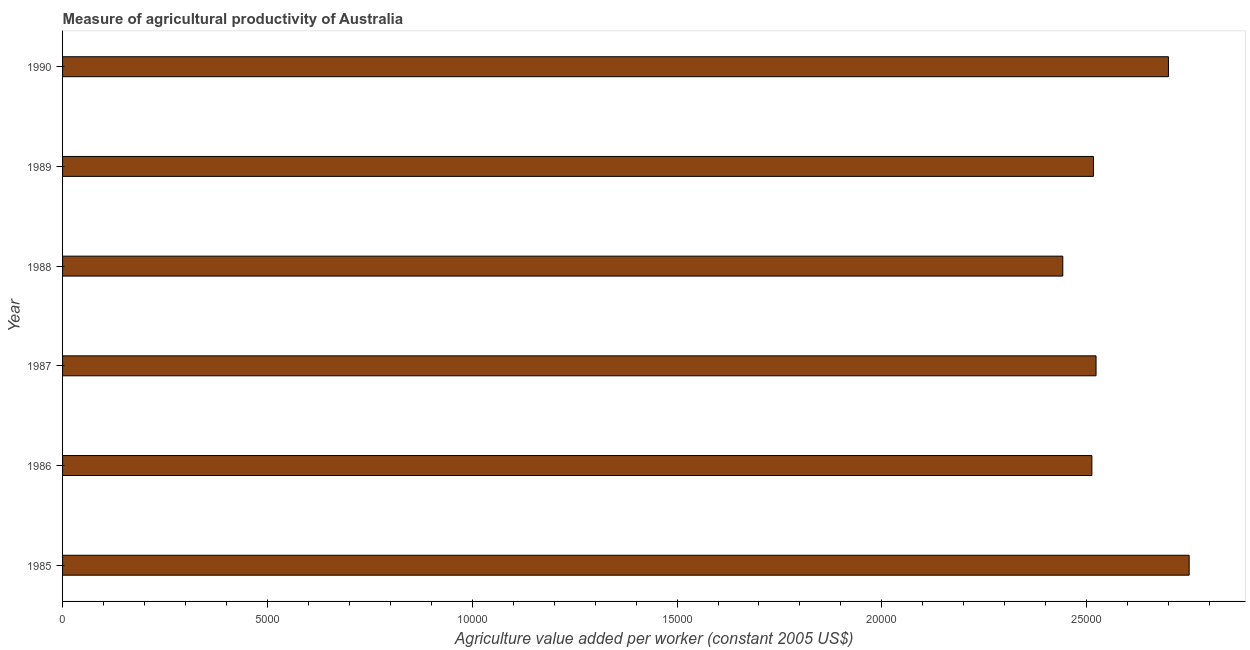Does the graph contain any zero values?
Provide a short and direct response. No. What is the title of the graph?
Keep it short and to the point. Measure of agricultural productivity of Australia. What is the label or title of the X-axis?
Your answer should be very brief. Agriculture value added per worker (constant 2005 US$). What is the agriculture value added per worker in 1989?
Your answer should be compact. 2.52e+04. Across all years, what is the maximum agriculture value added per worker?
Provide a succinct answer. 2.75e+04. Across all years, what is the minimum agriculture value added per worker?
Your response must be concise. 2.44e+04. What is the sum of the agriculture value added per worker?
Ensure brevity in your answer.  1.54e+05. What is the difference between the agriculture value added per worker in 1986 and 1988?
Make the answer very short. 710.05. What is the average agriculture value added per worker per year?
Offer a very short reply. 2.57e+04. What is the median agriculture value added per worker?
Make the answer very short. 2.52e+04. In how many years, is the agriculture value added per worker greater than 9000 US$?
Make the answer very short. 6. Is the agriculture value added per worker in 1989 less than that in 1990?
Your answer should be compact. Yes. What is the difference between the highest and the second highest agriculture value added per worker?
Offer a terse response. 506.07. What is the difference between the highest and the lowest agriculture value added per worker?
Provide a short and direct response. 3084.77. In how many years, is the agriculture value added per worker greater than the average agriculture value added per worker taken over all years?
Provide a succinct answer. 2. How many years are there in the graph?
Your answer should be compact. 6. What is the difference between two consecutive major ticks on the X-axis?
Give a very brief answer. 5000. What is the Agriculture value added per worker (constant 2005 US$) of 1985?
Your answer should be very brief. 2.75e+04. What is the Agriculture value added per worker (constant 2005 US$) of 1986?
Give a very brief answer. 2.51e+04. What is the Agriculture value added per worker (constant 2005 US$) in 1987?
Keep it short and to the point. 2.52e+04. What is the Agriculture value added per worker (constant 2005 US$) in 1988?
Provide a succinct answer. 2.44e+04. What is the Agriculture value added per worker (constant 2005 US$) of 1989?
Ensure brevity in your answer.  2.52e+04. What is the Agriculture value added per worker (constant 2005 US$) of 1990?
Your response must be concise. 2.70e+04. What is the difference between the Agriculture value added per worker (constant 2005 US$) in 1985 and 1986?
Your answer should be very brief. 2374.72. What is the difference between the Agriculture value added per worker (constant 2005 US$) in 1985 and 1987?
Give a very brief answer. 2272.86. What is the difference between the Agriculture value added per worker (constant 2005 US$) in 1985 and 1988?
Provide a short and direct response. 3084.77. What is the difference between the Agriculture value added per worker (constant 2005 US$) in 1985 and 1989?
Your response must be concise. 2336.24. What is the difference between the Agriculture value added per worker (constant 2005 US$) in 1985 and 1990?
Make the answer very short. 506.07. What is the difference between the Agriculture value added per worker (constant 2005 US$) in 1986 and 1987?
Provide a short and direct response. -101.86. What is the difference between the Agriculture value added per worker (constant 2005 US$) in 1986 and 1988?
Make the answer very short. 710.05. What is the difference between the Agriculture value added per worker (constant 2005 US$) in 1986 and 1989?
Make the answer very short. -38.48. What is the difference between the Agriculture value added per worker (constant 2005 US$) in 1986 and 1990?
Provide a short and direct response. -1868.65. What is the difference between the Agriculture value added per worker (constant 2005 US$) in 1987 and 1988?
Your answer should be compact. 811.9. What is the difference between the Agriculture value added per worker (constant 2005 US$) in 1987 and 1989?
Provide a succinct answer. 63.38. What is the difference between the Agriculture value added per worker (constant 2005 US$) in 1987 and 1990?
Offer a very short reply. -1766.8. What is the difference between the Agriculture value added per worker (constant 2005 US$) in 1988 and 1989?
Your answer should be compact. -748.53. What is the difference between the Agriculture value added per worker (constant 2005 US$) in 1988 and 1990?
Offer a terse response. -2578.7. What is the difference between the Agriculture value added per worker (constant 2005 US$) in 1989 and 1990?
Your answer should be very brief. -1830.17. What is the ratio of the Agriculture value added per worker (constant 2005 US$) in 1985 to that in 1986?
Your answer should be very brief. 1.09. What is the ratio of the Agriculture value added per worker (constant 2005 US$) in 1985 to that in 1987?
Offer a terse response. 1.09. What is the ratio of the Agriculture value added per worker (constant 2005 US$) in 1985 to that in 1988?
Ensure brevity in your answer.  1.13. What is the ratio of the Agriculture value added per worker (constant 2005 US$) in 1985 to that in 1989?
Ensure brevity in your answer.  1.09. What is the ratio of the Agriculture value added per worker (constant 2005 US$) in 1986 to that in 1988?
Provide a short and direct response. 1.03. What is the ratio of the Agriculture value added per worker (constant 2005 US$) in 1986 to that in 1989?
Provide a short and direct response. 1. What is the ratio of the Agriculture value added per worker (constant 2005 US$) in 1986 to that in 1990?
Make the answer very short. 0.93. What is the ratio of the Agriculture value added per worker (constant 2005 US$) in 1987 to that in 1988?
Your answer should be compact. 1.03. What is the ratio of the Agriculture value added per worker (constant 2005 US$) in 1987 to that in 1989?
Provide a short and direct response. 1. What is the ratio of the Agriculture value added per worker (constant 2005 US$) in 1987 to that in 1990?
Provide a short and direct response. 0.94. What is the ratio of the Agriculture value added per worker (constant 2005 US$) in 1988 to that in 1989?
Offer a very short reply. 0.97. What is the ratio of the Agriculture value added per worker (constant 2005 US$) in 1988 to that in 1990?
Keep it short and to the point. 0.9. What is the ratio of the Agriculture value added per worker (constant 2005 US$) in 1989 to that in 1990?
Give a very brief answer. 0.93. 